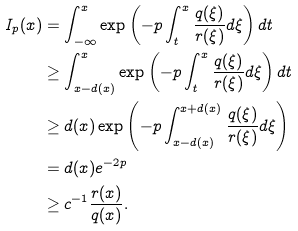<formula> <loc_0><loc_0><loc_500><loc_500>I _ { p } ( x ) & = \int _ { - \infty } ^ { x } \exp \left ( - p \int _ { t } ^ { x } \frac { q ( \xi ) } { r ( \xi ) } d \xi \right ) d t \\ & \geq \int _ { x - d ( x ) } ^ { x } \exp \left ( - p \int _ { t } ^ { x } \frac { q ( \xi ) } { r ( \xi ) } d \xi \right ) d t \\ & \geq d ( x ) \exp \left ( - p \int _ { x - d ( x ) } ^ { x + d ( x ) } \frac { q ( \xi ) } { r ( \xi ) } d \xi \right ) \\ & = d ( x ) e ^ { - 2 p } \\ & \geq c ^ { - 1 } \frac { r ( x ) } { q ( x ) } .</formula> 